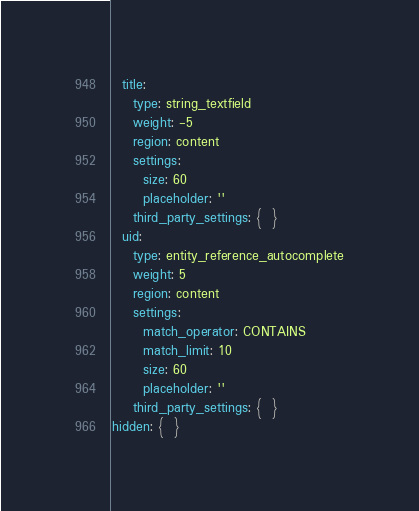Convert code to text. <code><loc_0><loc_0><loc_500><loc_500><_YAML_>  title:
    type: string_textfield
    weight: -5
    region: content
    settings:
      size: 60
      placeholder: ''
    third_party_settings: {  }
  uid:
    type: entity_reference_autocomplete
    weight: 5
    region: content
    settings:
      match_operator: CONTAINS
      match_limit: 10
      size: 60
      placeholder: ''
    third_party_settings: {  }
hidden: {  }
</code> 